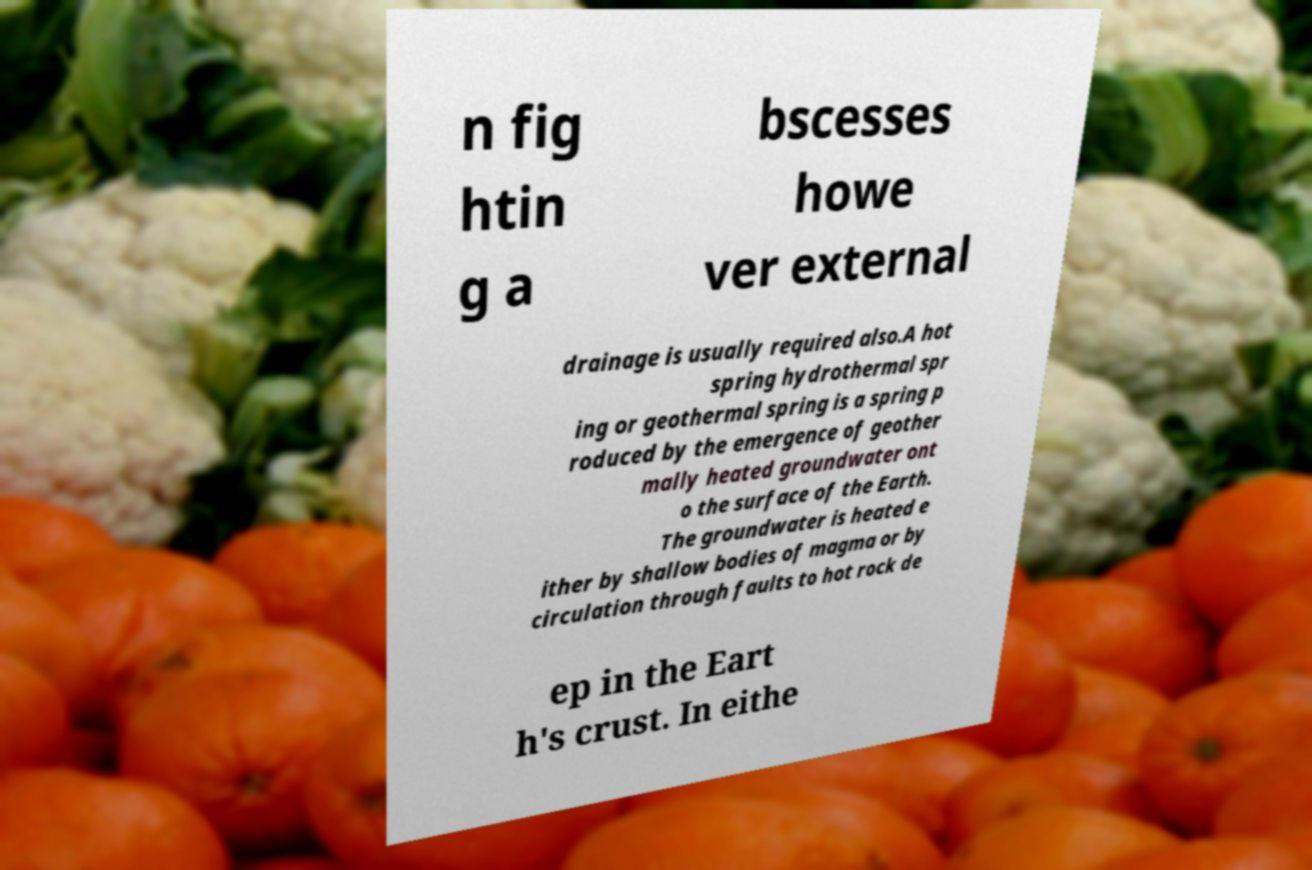Could you extract and type out the text from this image? n fig htin g a bscesses howe ver external drainage is usually required also.A hot spring hydrothermal spr ing or geothermal spring is a spring p roduced by the emergence of geother mally heated groundwater ont o the surface of the Earth. The groundwater is heated e ither by shallow bodies of magma or by circulation through faults to hot rock de ep in the Eart h's crust. In eithe 